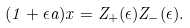<formula> <loc_0><loc_0><loc_500><loc_500>( 1 + \epsilon a ) x = Z _ { + } ( \epsilon ) Z _ { - } ( \epsilon ) .</formula> 